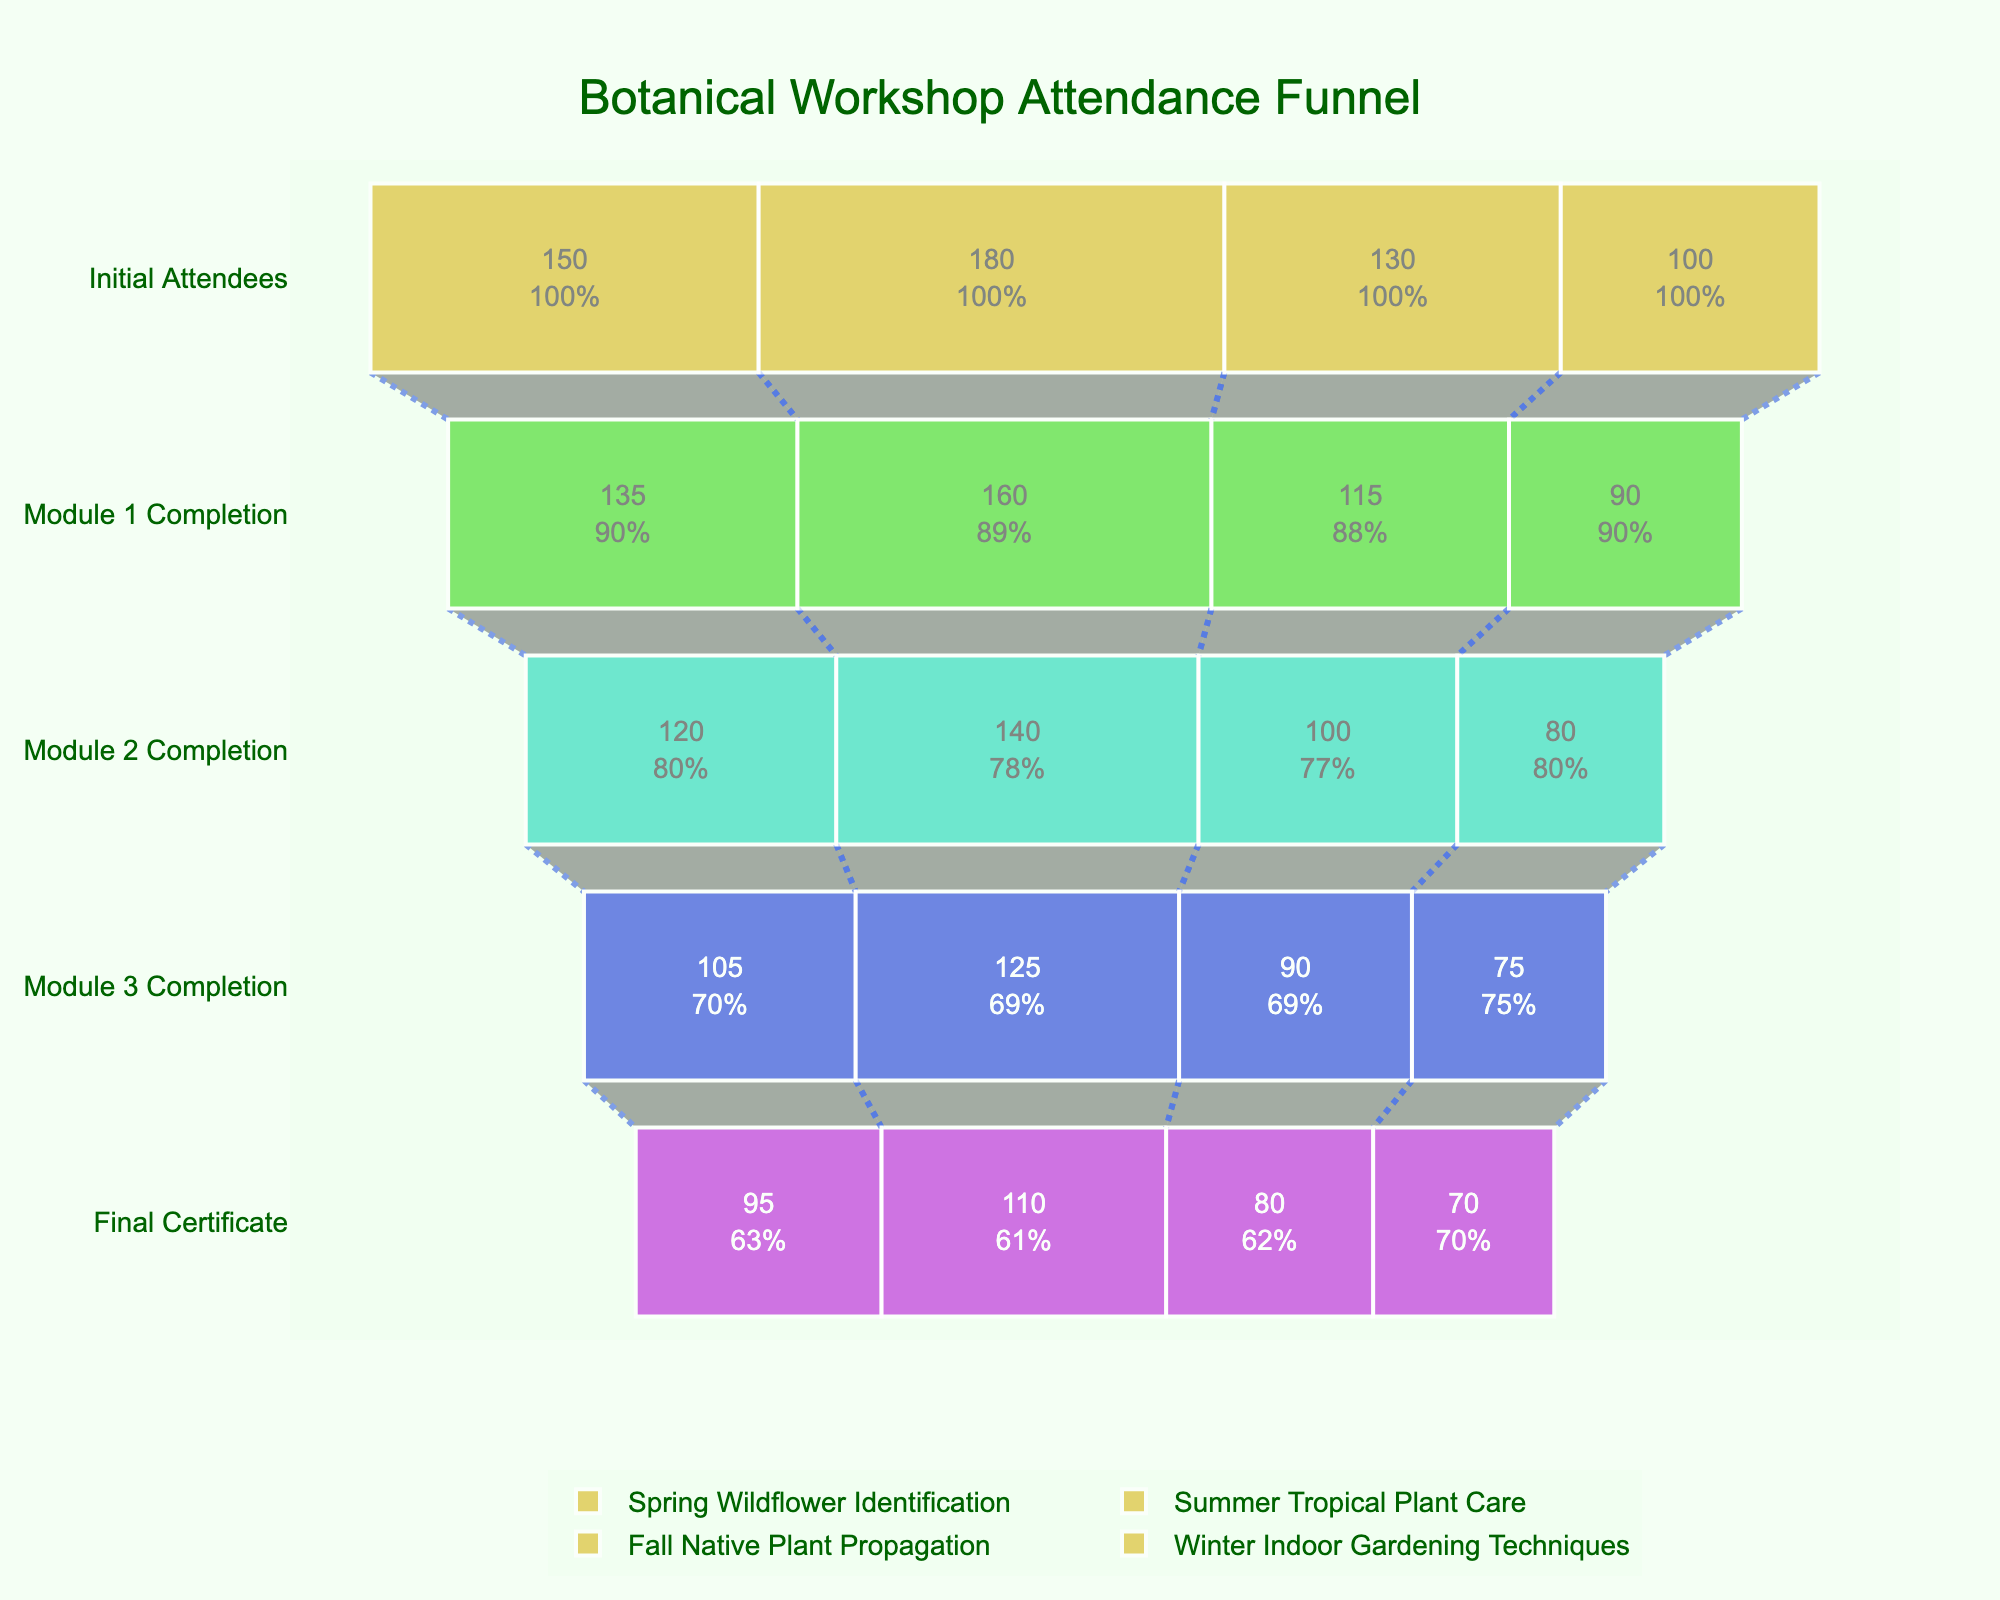What is the title of the funnel chart? The title of the funnel chart is usually displayed at the top center of the figure. In this chart, it's clearly stated.
Answer: "Botanical Workshop Attendance Funnel" How many workshops are compared in this funnel chart? Count the traces represented in the funnel chart. Each trace represents a different workshop.
Answer: Four Which workshop had the most initial attendees? Look at the values for the 'Initial Attendees' stage across all workshops and identify the highest value.
Answer: Summer Tropical Plant Care What percentage of Spring Wildflower Identification attendees completed Module 1? Identify the 'Spring Wildflower Identification' trace and note the ratio of 'Module 1 Completion' to 'Initial Attendees', then calculate the percentage.
Answer: 90% How many attendees received the Final Certificate for the Winter Indoor Gardening Techniques workshop? Identify the value at the 'Final Certificate' stage for the 'Winter Indoor Gardening Techniques' trace.
Answer: 70 Which workshop had the largest drop-off rate between Initial Attendees and Final Certificate? Calculate the difference between 'Initial Attendees' and 'Final Certificate' for each workshop, then identify the maximum drop-off.
Answer: Summer Tropical Plant Care (70 attendees) Compare the retention rate from Initial Attendees to Final Certificate for Fall Native Plant Propagation and Winter Indoor Gardening Techniques. Which is better? Calculate the retention rate for both workshops as (Final Certificate / Initial Attendees) * 100 and compare the values.
Answer: Winter Indoor Gardening Techniques (70/100 = 70%) is better than Fall Native Plant Propagation (80/130 ≈ 61.5%) What is the average number of Initial Attendees across all workshops? Sum the Initial Attendees for all workshops and divide by the number of workshops to find the average.
Answer: (150 + 180 + 130 + 100) / 4 = 140 